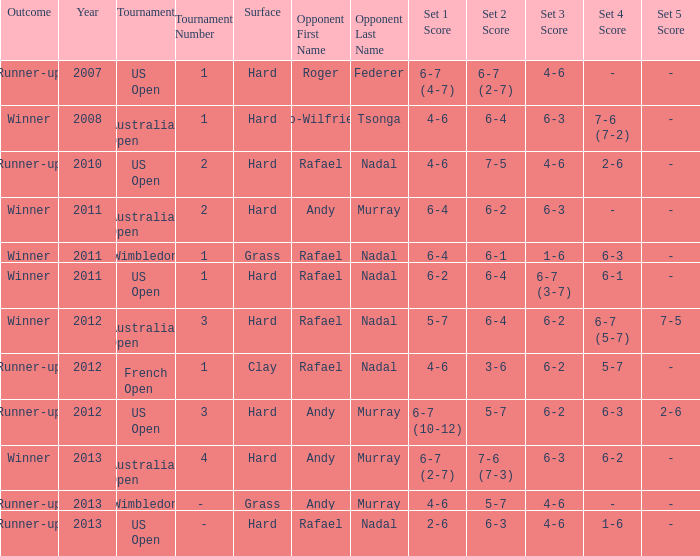What is the outcome of the 4–6, 6–4, 6–3, 7–6 (7–2) score? Winner. 